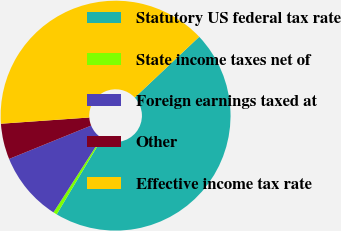<chart> <loc_0><loc_0><loc_500><loc_500><pie_chart><fcel>Statutory US federal tax rate<fcel>State income taxes net of<fcel>Foreign earnings taxed at<fcel>Other<fcel>Effective income tax rate<nl><fcel>45.6%<fcel>0.52%<fcel>9.77%<fcel>5.03%<fcel>39.08%<nl></chart> 